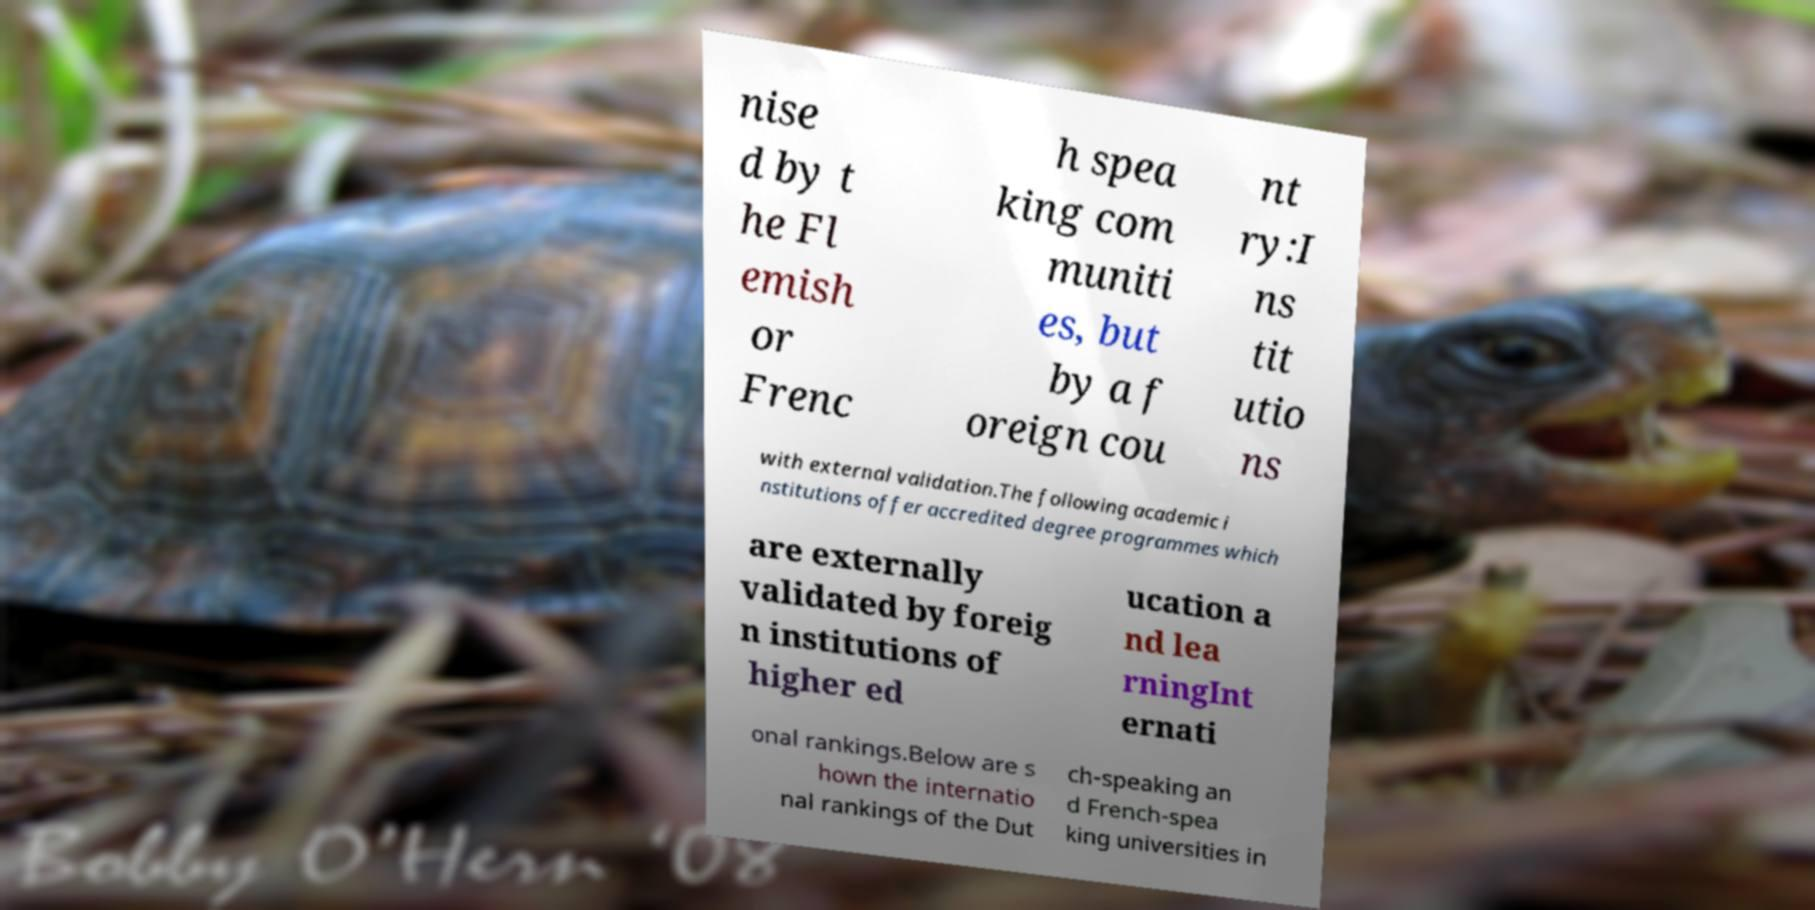Can you read and provide the text displayed in the image?This photo seems to have some interesting text. Can you extract and type it out for me? nise d by t he Fl emish or Frenc h spea king com muniti es, but by a f oreign cou nt ry:I ns tit utio ns with external validation.The following academic i nstitutions offer accredited degree programmes which are externally validated by foreig n institutions of higher ed ucation a nd lea rningInt ernati onal rankings.Below are s hown the internatio nal rankings of the Dut ch-speaking an d French-spea king universities in 